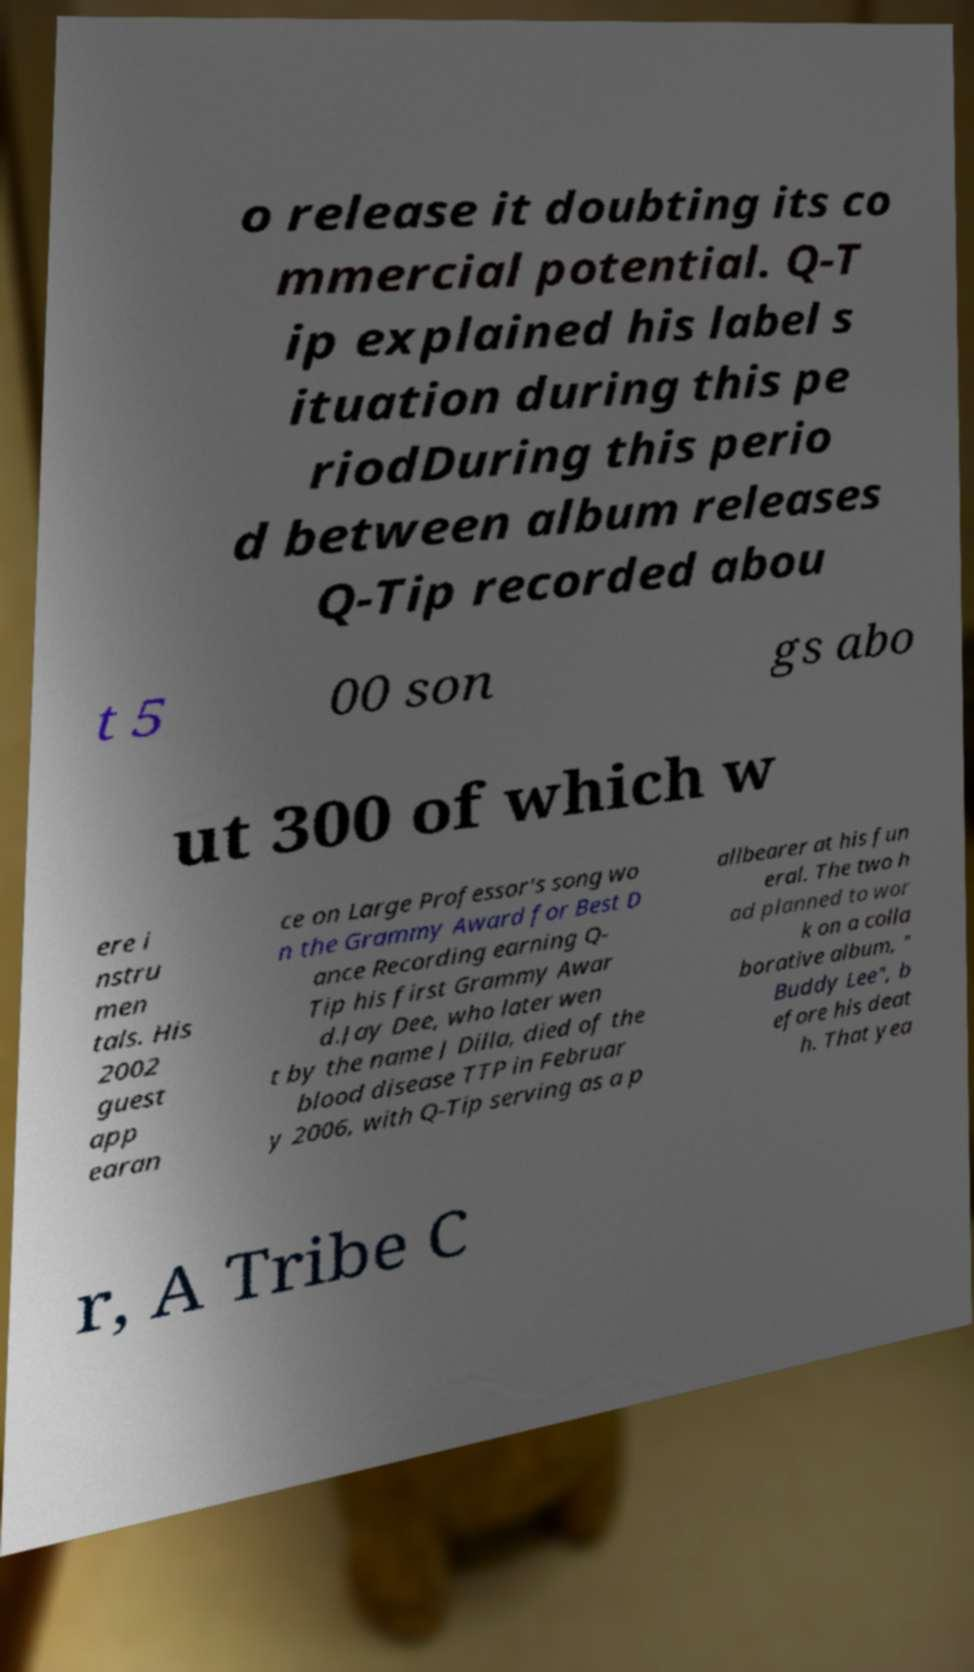Could you assist in decoding the text presented in this image and type it out clearly? o release it doubting its co mmercial potential. Q-T ip explained his label s ituation during this pe riodDuring this perio d between album releases Q-Tip recorded abou t 5 00 son gs abo ut 300 of which w ere i nstru men tals. His 2002 guest app earan ce on Large Professor's song wo n the Grammy Award for Best D ance Recording earning Q- Tip his first Grammy Awar d.Jay Dee, who later wen t by the name J Dilla, died of the blood disease TTP in Februar y 2006, with Q-Tip serving as a p allbearer at his fun eral. The two h ad planned to wor k on a colla borative album, " Buddy Lee", b efore his deat h. That yea r, A Tribe C 